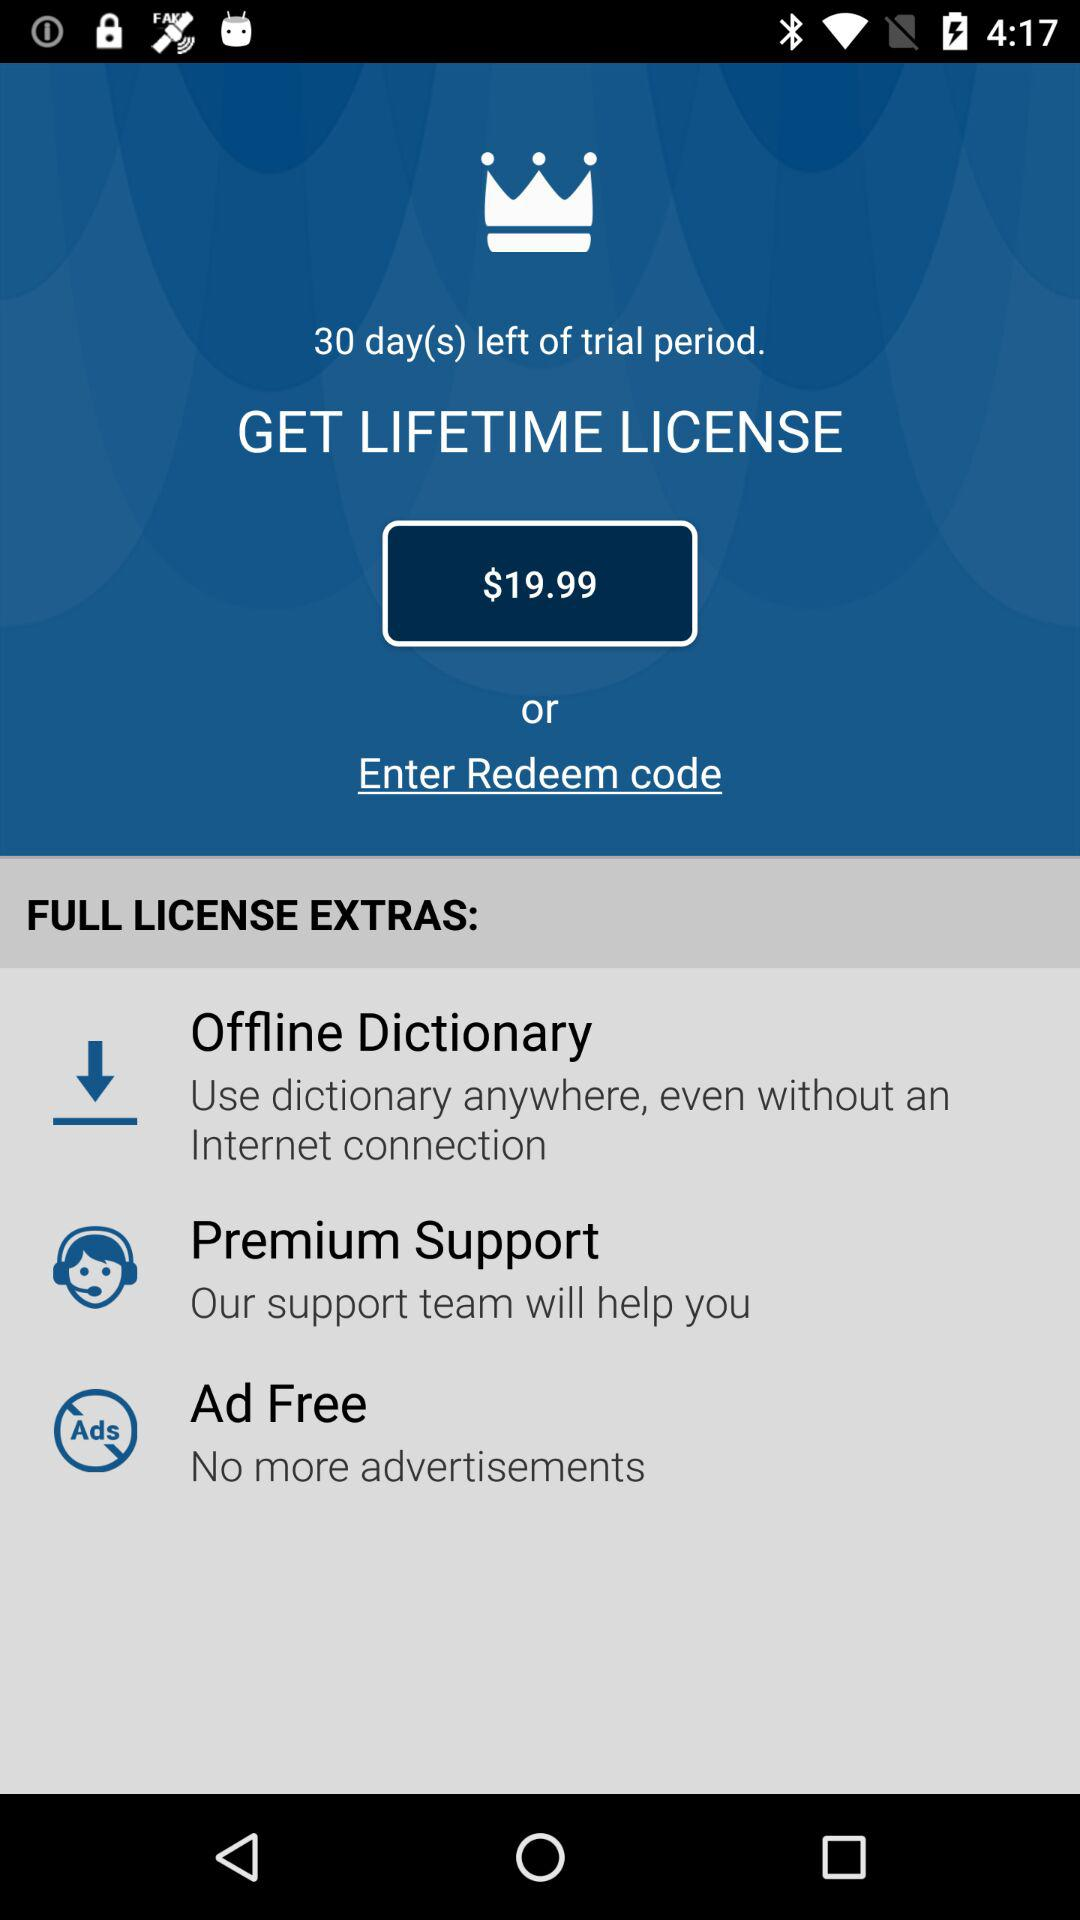What is the cost of a lifetime license? The cost of a lifetime license is $19.99. 